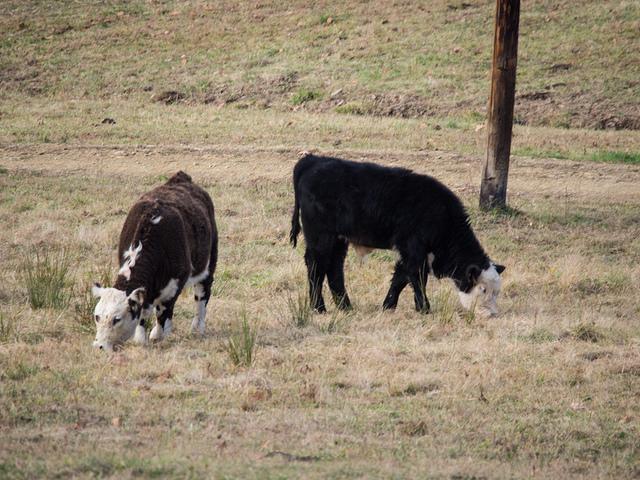How many cattle are on the field?
Give a very brief answer. 2. How many cows are there?
Give a very brief answer. 2. 